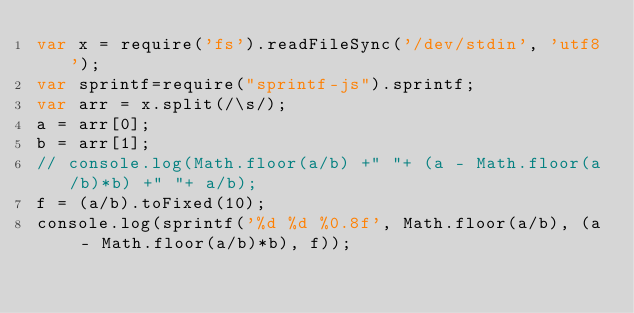<code> <loc_0><loc_0><loc_500><loc_500><_JavaScript_>var x = require('fs').readFileSync('/dev/stdin', 'utf8');
var sprintf=require("sprintf-js").sprintf;
var arr = x.split(/\s/);
a = arr[0];
b = arr[1];
// console.log(Math.floor(a/b) +" "+ (a - Math.floor(a/b)*b) +" "+ a/b);
f = (a/b).toFixed(10);
console.log(sprintf('%d %d %0.8f', Math.floor(a/b), (a - Math.floor(a/b)*b), f));

</code> 